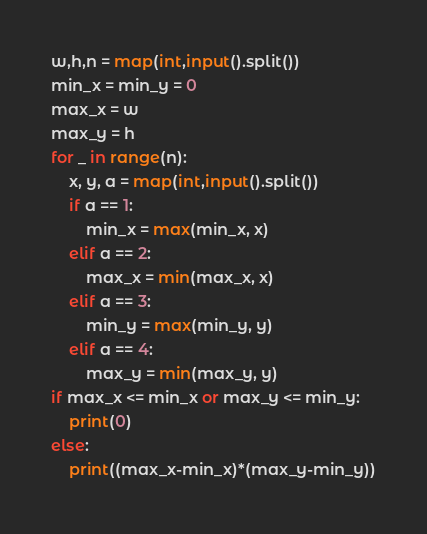<code> <loc_0><loc_0><loc_500><loc_500><_Python_>w,h,n = map(int,input().split())
min_x = min_y = 0
max_x = w
max_y = h
for _ in range(n):
    x, y, a = map(int,input().split())
    if a == 1:
        min_x = max(min_x, x)
    elif a == 2:
        max_x = min(max_x, x)
    elif a == 3:
        min_y = max(min_y, y)
    elif a == 4:
        max_y = min(max_y, y)
if max_x <= min_x or max_y <= min_y:
    print(0)
else:
    print((max_x-min_x)*(max_y-min_y))
</code> 